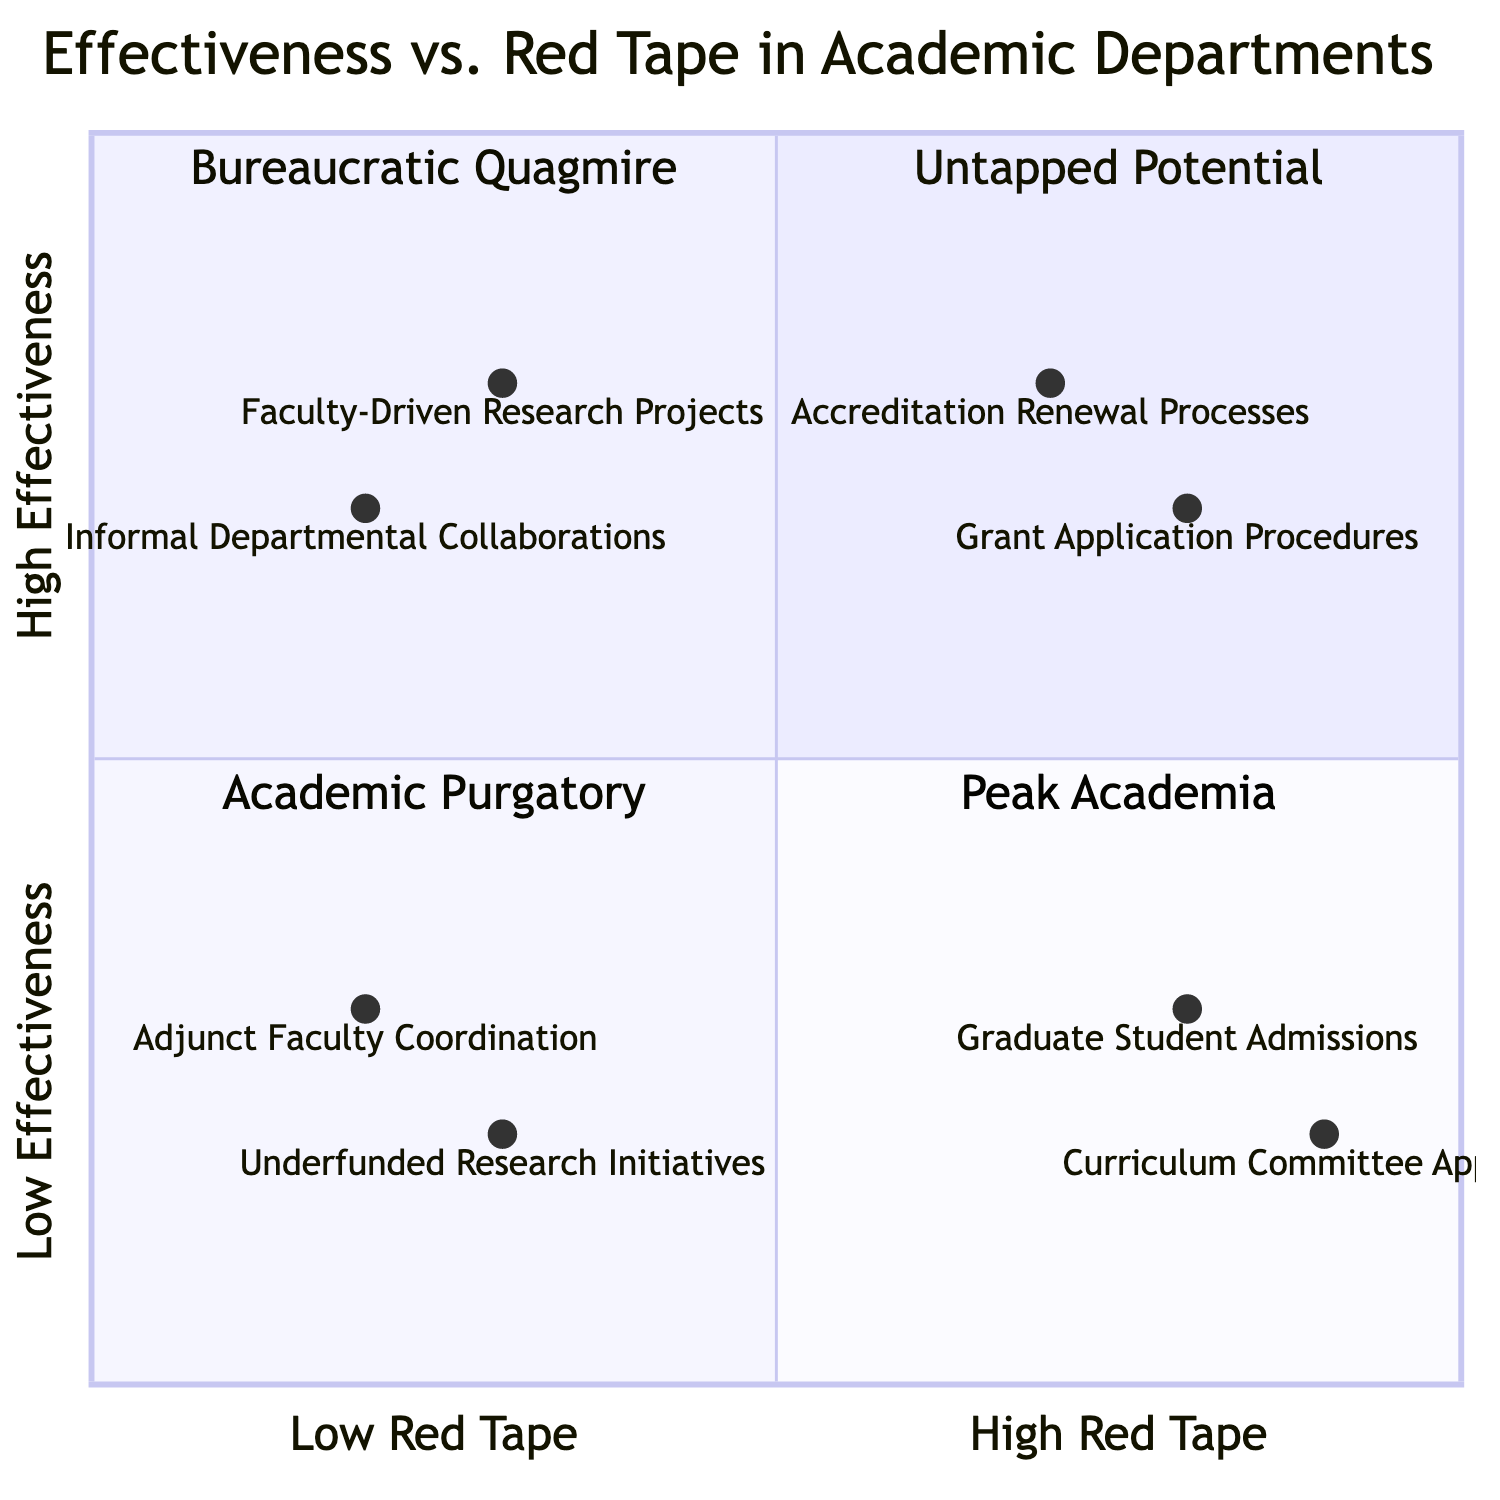What's in the Low Effectiveness/Low Red Tape quadrant? The Low Effectiveness/Low Red Tape quadrant includes two elements: Adjunct Faculty Coordination and Underfunded Research Initiatives. This information is directly taken from the diagram where these elements are categorized.
Answer: Adjunct Faculty Coordination, Underfunded Research Initiatives How many elements are in the High Effectiveness/High Red Tape quadrant? There are two elements located in the High Effectiveness/High Red Tape quadrant, which are Accreditation Renewal Processes and Grant Application Procedures, as shown in that section of the chart.
Answer: 2 Which element has the highest effectiveness with low red tape? The element that has the highest effectiveness with low red tape is Faculty-Driven Research Projects, located in the High Effectiveness/Low Red Tape quadrant of the diagram.
Answer: Faculty-Driven Research Projects In which quadrant are Graduate Student Admissions located? Graduate Student Admissions is located in the Low Effectiveness/High Red Tape quadrant. This is determined by finding the element listed and checking its corresponding quadrant on the diagram.
Answer: Low Effectiveness/High Red Tape Which quadrant has the element with the highest combination of effectiveness and red tape? The High Effectiveness/High Red Tape quadrant contains the elements with the highest combination of effectiveness and red tape, specifically Accreditation Renewal Processes and Grant Application Procedures, which are in this quadrant due to their scores.
Answer: High Effectiveness/High Red Tape How many elements fall into the Academic Purgatory quadrant? There are four elements that fall into the Academic Purgatory quadrant, which corresponds to the Low Effectiveness/High Red Tape quadrant in the chart—Graduate Student Admissions and Curriculum Committee Approvals are included here, totaling two elements.
Answer: 2 What is the effectiveness rating of Informal Departmental Collaborations? Informal Departmental Collaborations has an effectiveness rating observed at 0.7 on the vertical axis, as shown in the High Effectiveness/Low Red Tape quadrant where it's located.
Answer: 0.7 Which of the quadrants has elements that are characterized as “Bureaucratic Quagmire”? The quadrant characterized as “Bureaucratic Quagmire” corresponds to the Low Effectiveness/High Red Tape quadrant, where Graduate Student Admissions and Curriculum Committee Approvals are located.
Answer: Bureaucratic Quagmire 